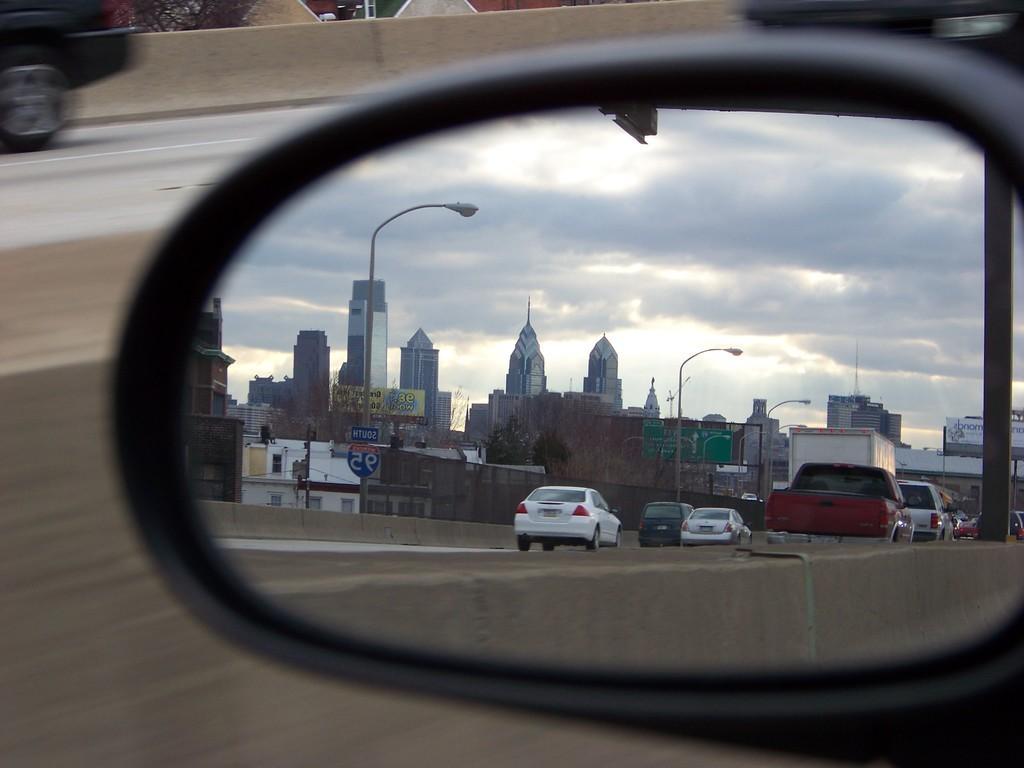How would you summarize this image in a sentence or two? In this picture I can observe side mirror of a vehicle. In the mirror I can observe some cars moving on the road. In the background there are buildings and some clouds in the sky. 